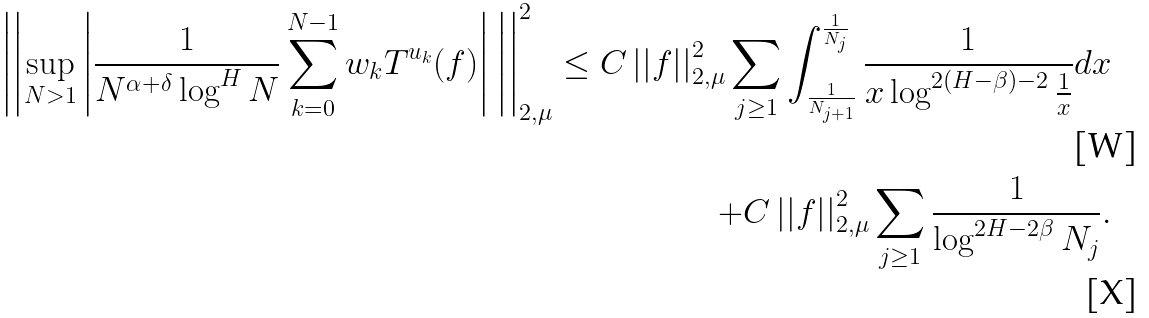<formula> <loc_0><loc_0><loc_500><loc_500>\left | \left | \sup _ { N > 1 } \left | \frac { 1 } { N ^ { \alpha + \delta } \log ^ { H } N } \sum _ { k = 0 } ^ { N - 1 } w _ { k } T ^ { u _ { k } } ( f ) \right | \, \right | \right | _ { 2 , \mu } ^ { 2 } \leq C \left | \left | f \right | \right | _ { 2 , \mu } ^ { 2 } \sum _ { j \geq 1 } \int _ { \frac { 1 } { N _ { j + 1 } } } ^ { \frac { 1 } { N _ { j } } } \frac { 1 } { x \log ^ { 2 ( H - \beta ) - 2 } \frac { 1 } { x } } d x \\ + C \left | \left | f \right | \right | _ { 2 , \mu } ^ { 2 } \sum _ { j \geq 1 } \frac { 1 } { \log ^ { 2 H - 2 \beta } N _ { j } } .</formula> 